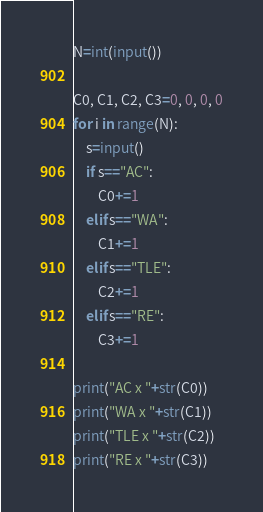<code> <loc_0><loc_0><loc_500><loc_500><_Python_>N=int(input())

C0, C1, C2, C3=0, 0, 0, 0
for i in range(N):
    s=input()
    if s=="AC":
        C0+=1
    elif s=="WA":
        C1+=1
    elif s=="TLE":
        C2+=1
    elif s=="RE":
        C3+=1
        
print("AC x "+str(C0))
print("WA x "+str(C1))
print("TLE x "+str(C2))
print("RE x "+str(C3))</code> 